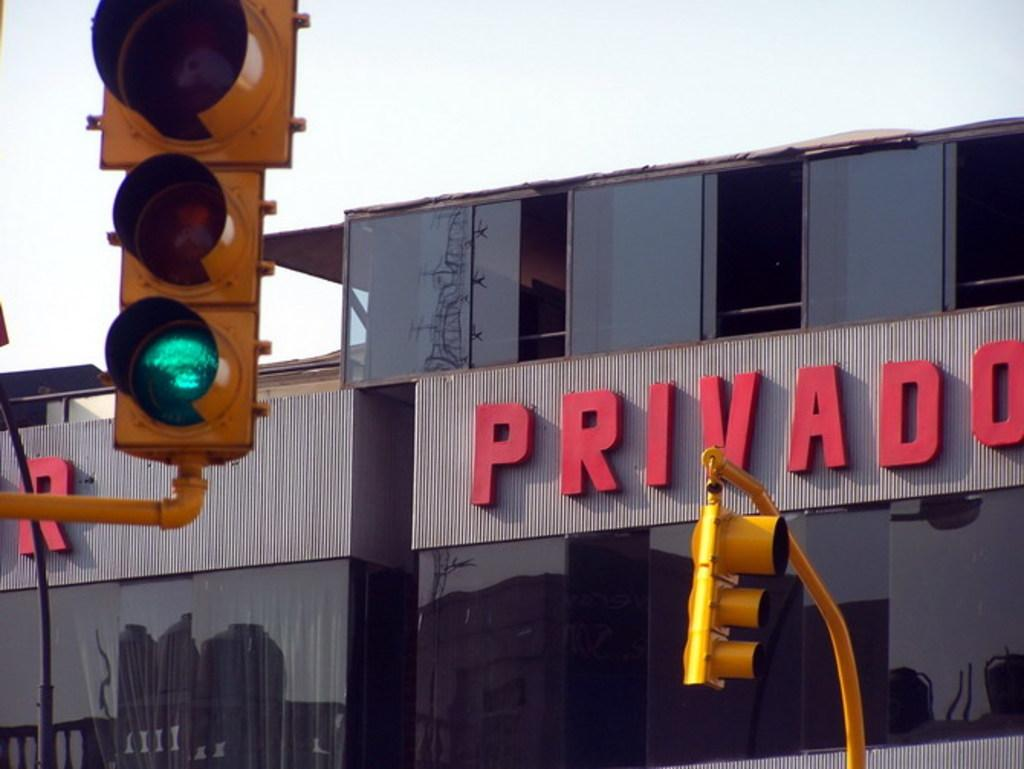<image>
Give a short and clear explanation of the subsequent image. A building for the company Privado is seen behind traffic lights. 